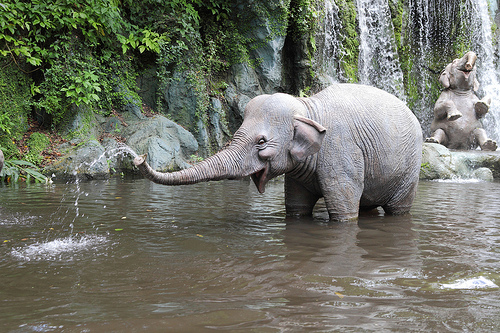Are there either elephants or fences? Yes, there is an elephant visible in the image. 